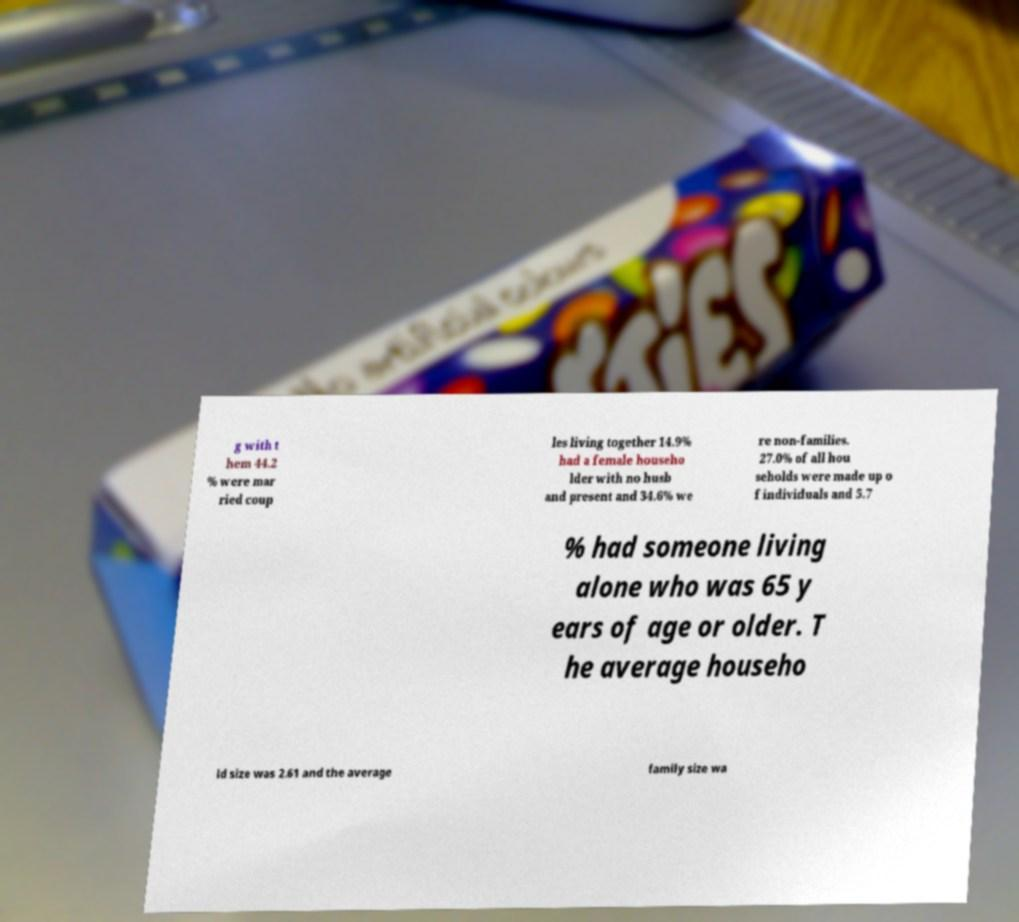For documentation purposes, I need the text within this image transcribed. Could you provide that? g with t hem 44.2 % were mar ried coup les living together 14.9% had a female househo lder with no husb and present and 34.6% we re non-families. 27.0% of all hou seholds were made up o f individuals and 5.7 % had someone living alone who was 65 y ears of age or older. T he average househo ld size was 2.61 and the average family size wa 